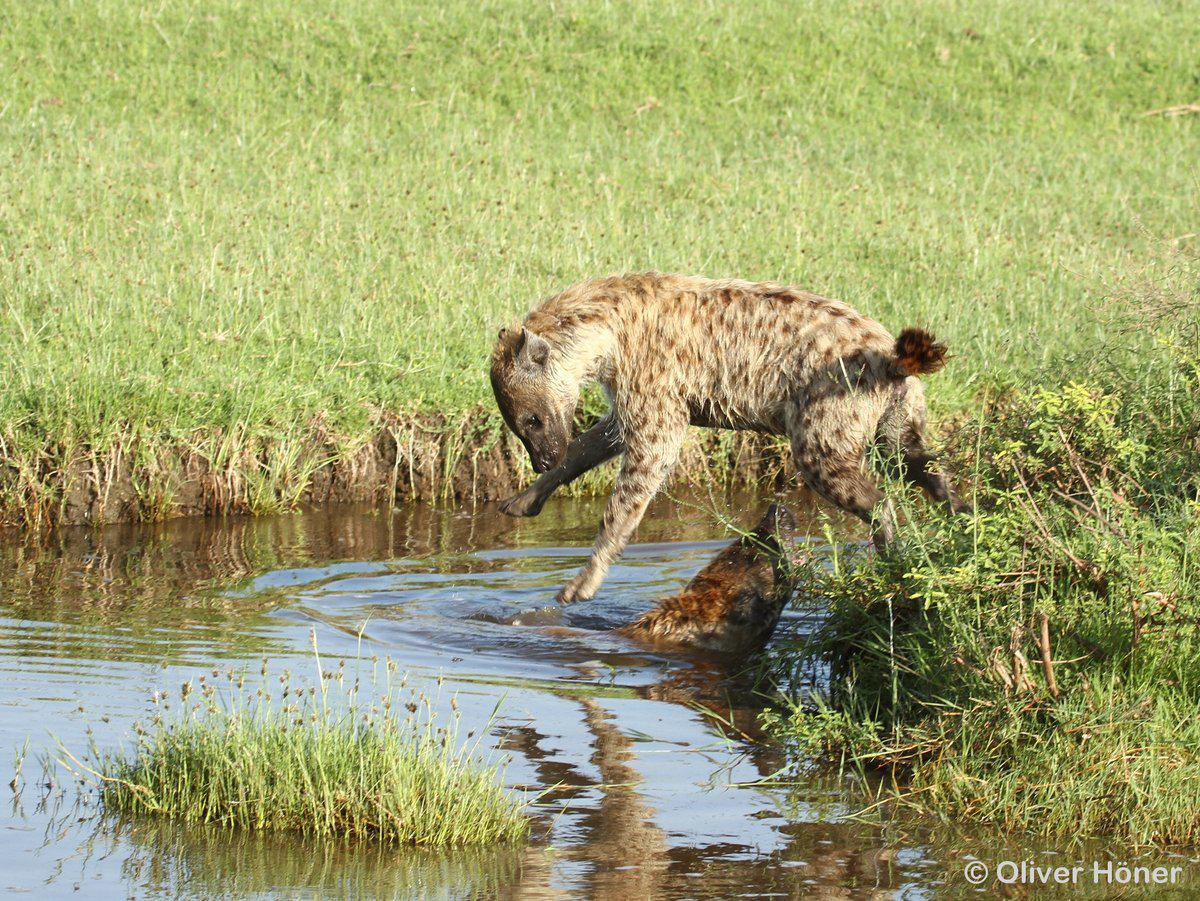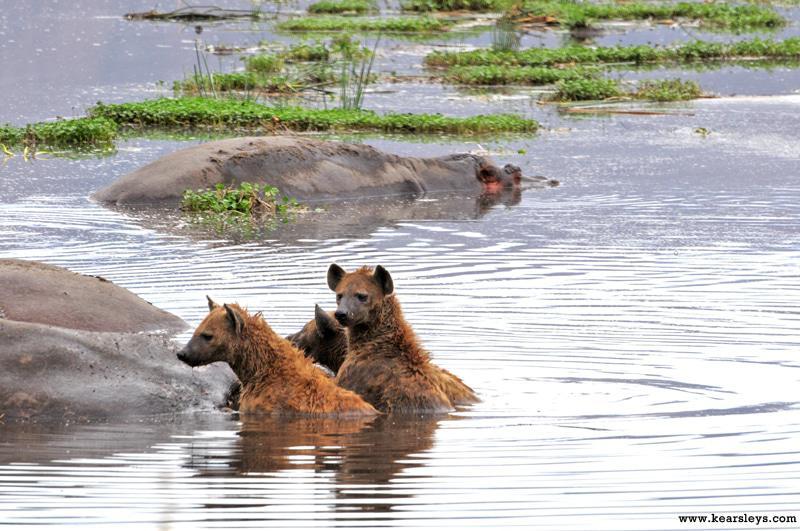The first image is the image on the left, the second image is the image on the right. Assess this claim about the two images: "The left and right image contains the same number of hyenas in the water.". Correct or not? Answer yes or no. No. The first image is the image on the left, the second image is the image on the right. Assess this claim about the two images: "The right image shows one hyena on its back in water, with its head and at least its front paws sticking up in the air.". Correct or not? Answer yes or no. No. 